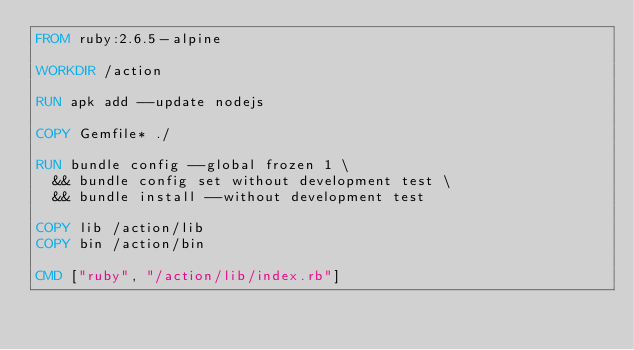Convert code to text. <code><loc_0><loc_0><loc_500><loc_500><_Dockerfile_>FROM ruby:2.6.5-alpine

WORKDIR /action

RUN apk add --update nodejs

COPY Gemfile* ./

RUN bundle config --global frozen 1 \
  && bundle config set without development test \
  && bundle install --without development test

COPY lib /action/lib
COPY bin /action/bin

CMD ["ruby", "/action/lib/index.rb"]
</code> 